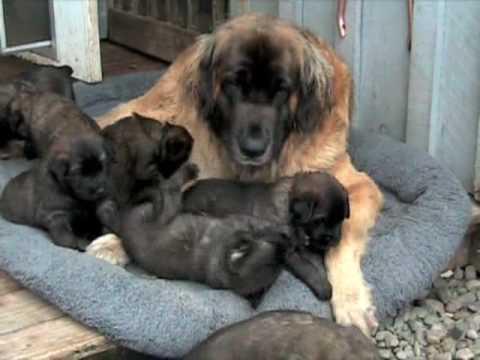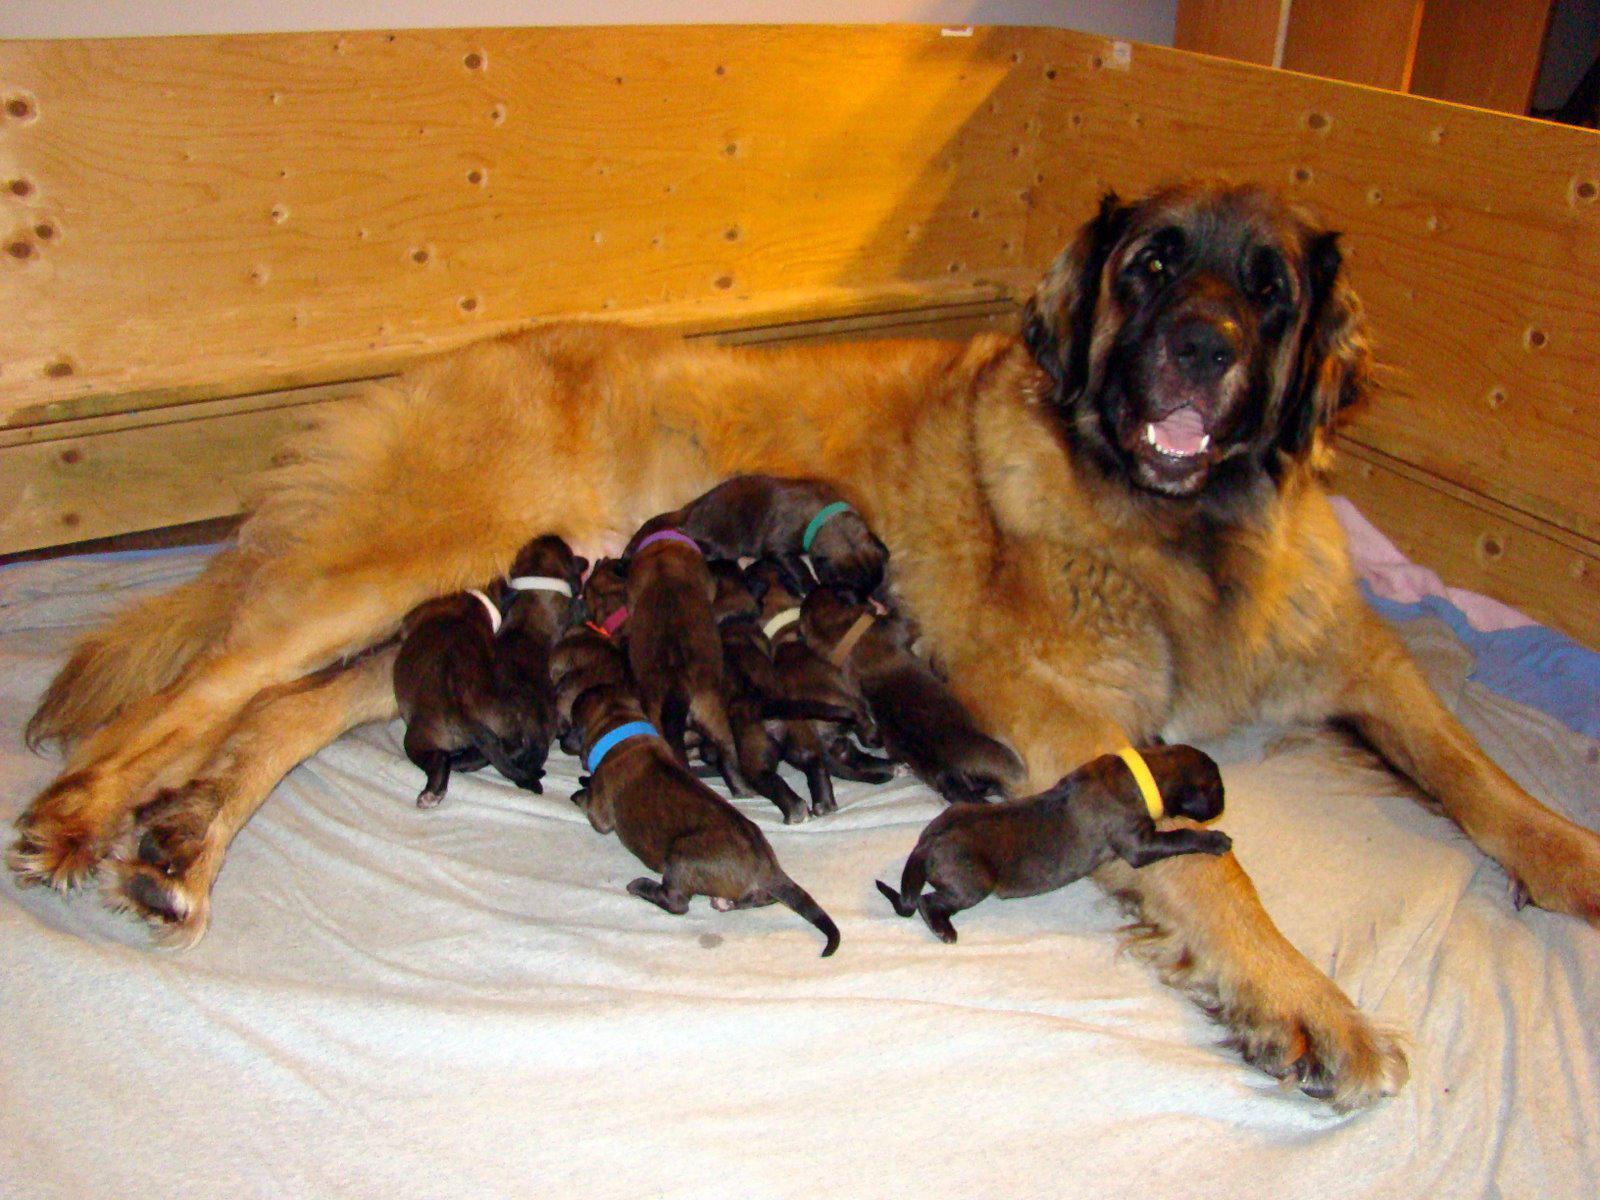The first image is the image on the left, the second image is the image on the right. For the images shown, is this caption "The dog in the image on the right is nursing in an area surrounded by wooden planks." true? Answer yes or no. Yes. The first image is the image on the left, the second image is the image on the right. Evaluate the accuracy of this statement regarding the images: "Right image shows a mother dog with raised head and her pups, surrounded by a natural wood border.". Is it true? Answer yes or no. Yes. The first image is the image on the left, the second image is the image on the right. Analyze the images presented: Is the assertion "An image shows multiple puppies on a gray rug with a paw print pattern." valid? Answer yes or no. No. The first image is the image on the left, the second image is the image on the right. Examine the images to the left and right. Is the description "Puppies are nursing on a puppy paw print rug in one of the images." accurate? Answer yes or no. No. 